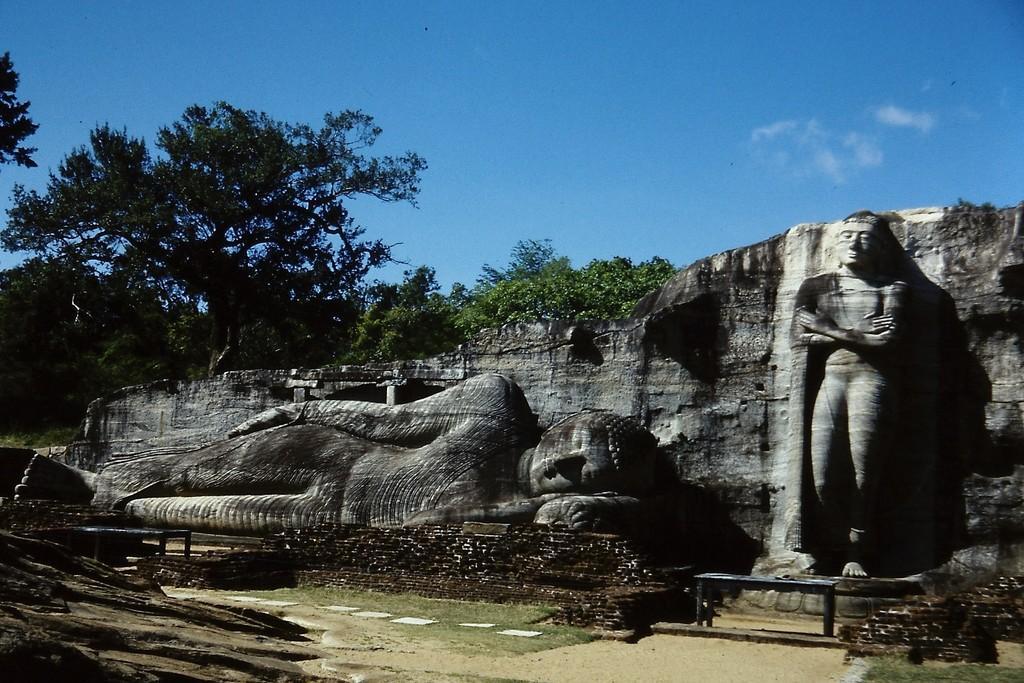Could you give a brief overview of what you see in this image? In this picture we can see two stone statue In the front there is a Buddha statue lying on the ground. On the right side there is a another statue which is standing. Behind there is a rock mountain and some trees. 